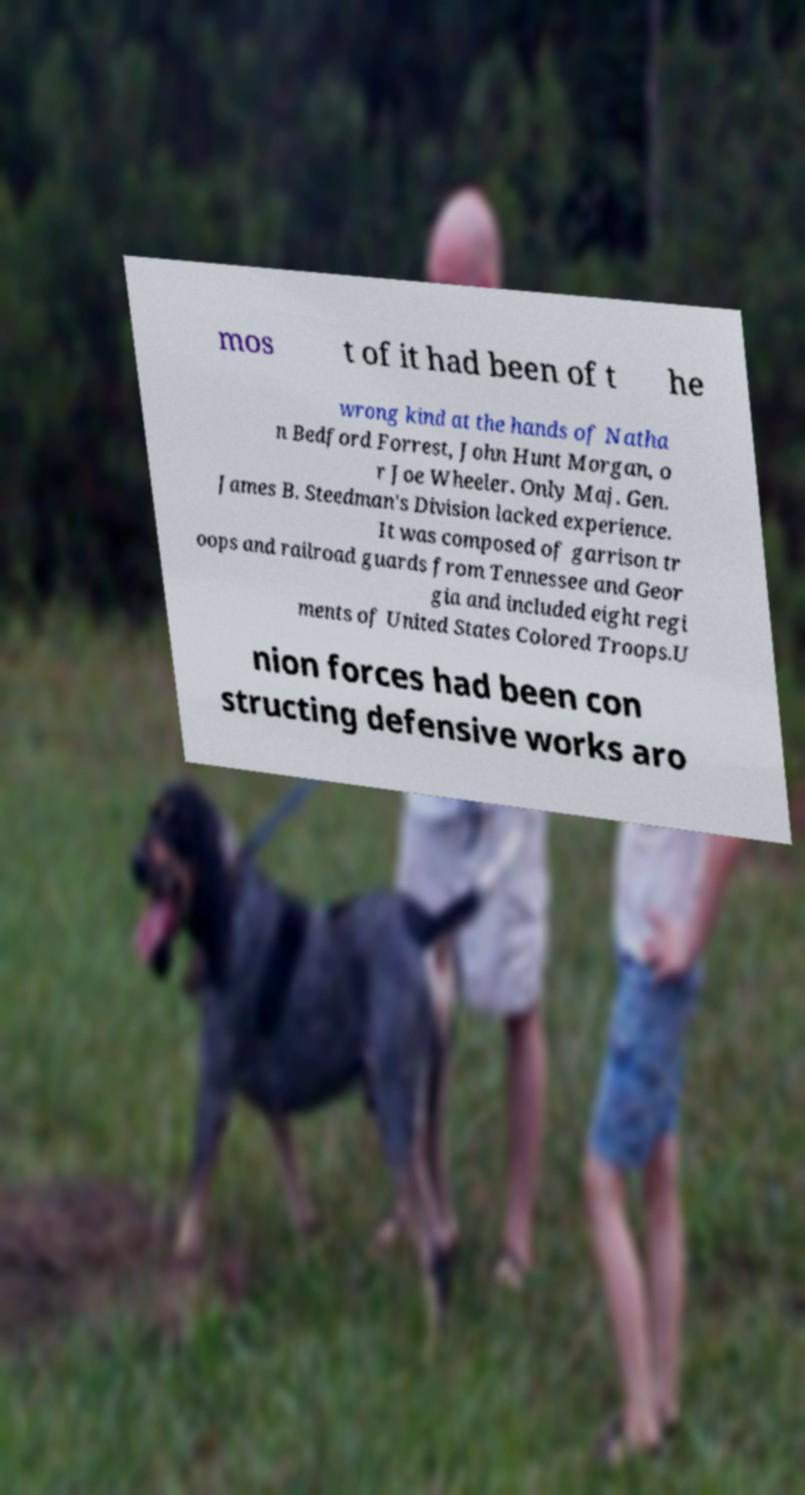I need the written content from this picture converted into text. Can you do that? mos t of it had been of t he wrong kind at the hands of Natha n Bedford Forrest, John Hunt Morgan, o r Joe Wheeler. Only Maj. Gen. James B. Steedman's Division lacked experience. It was composed of garrison tr oops and railroad guards from Tennessee and Geor gia and included eight regi ments of United States Colored Troops.U nion forces had been con structing defensive works aro 